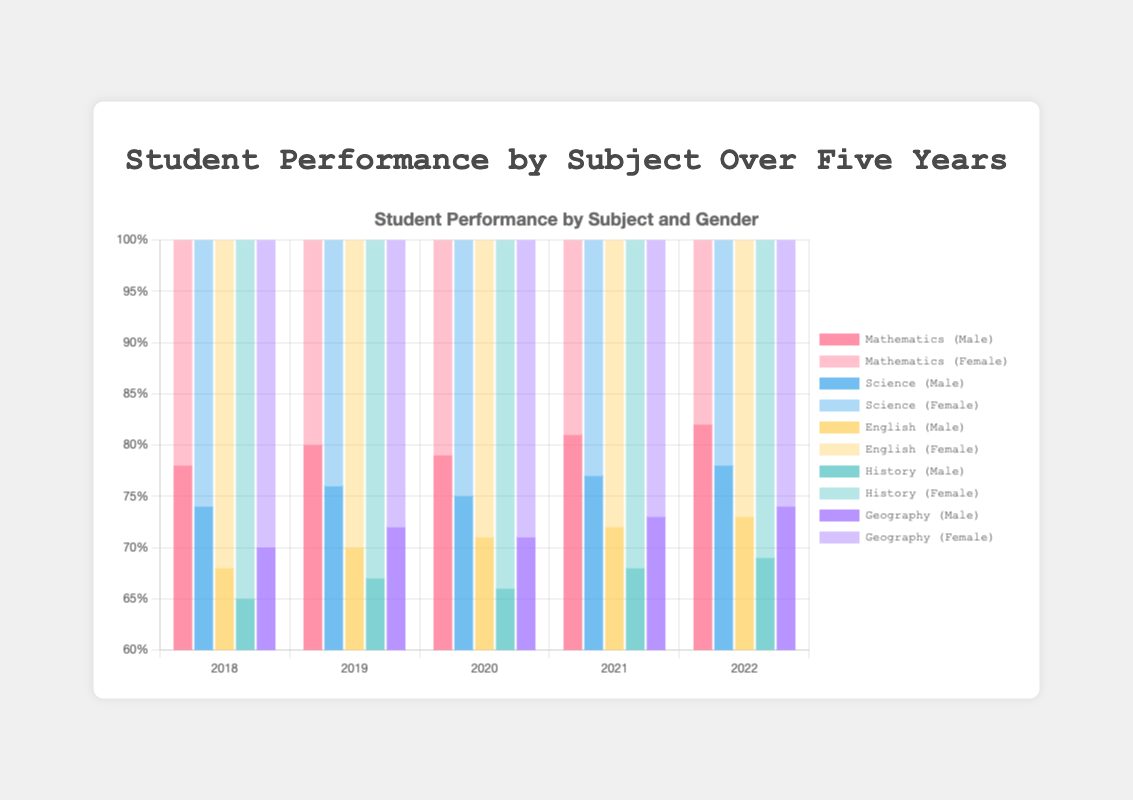Which subject has the highest female performance score in 2022? To find out which subject has the highest female performance score in 2022, look at the female scores for all subjects in that year. Geography has the highest score with 79.
Answer: Geography Over the five years, in which subject did male performance improve the most? Calculate the difference in male performance scores between 2022 and 2018 for all subjects. Mathematics improved the most, with an increase from 78 to 82 (an improvement of 4 points).
Answer: Mathematics Which subject showed a consistent increase in female performance every year? Identify the subject(s) for which the female performance score increases every year from 2018 to 2022. Mathematics showed a consistent increase, with scores of 82, 85, 83, 86, and 87.
Answer: Mathematics In 2021, how much higher were the female scores in Science compared to male scores in English? Find the female score for Science and the male score for English in 2021, then calculate the difference. The female score for Science was 83, and the male score for English was 72. The difference is 83 - 72 = 11.
Answer: 11 Compare the average performance of male students in Mathematics and Geography over the five years. Which is higher? Calculate the average score for male students in Mathematics and Geography from 2018 to 2022. Mathematics: (78+80+79+81+82)/5 = 80; Geography: (70+72+71+73+74)/5 = 72. The average performance in Mathematics is higher.
Answer: Mathematics Which subject had the smallest gender gap in performance in 2020, and what was the gap? Calculate the difference between male and female scores for each subject in 2020. The smallest gap is in English, with female 75 - male 71 = 4.
Answer: English, 4 In which year did males and females have the closest performance in History? Subtract male scores from female scores each year for History and identify the smallest difference. In 2020, the difference was smallest (71 - 66 = 5).
Answer: 2020 Which subject's male scores showed the least variation over the five years? Calculate the range (max - min) of male scores for each subject from 2018 to 2022. History had the least variation, with scores from 65 to 69 (range = 4).
Answer: History 